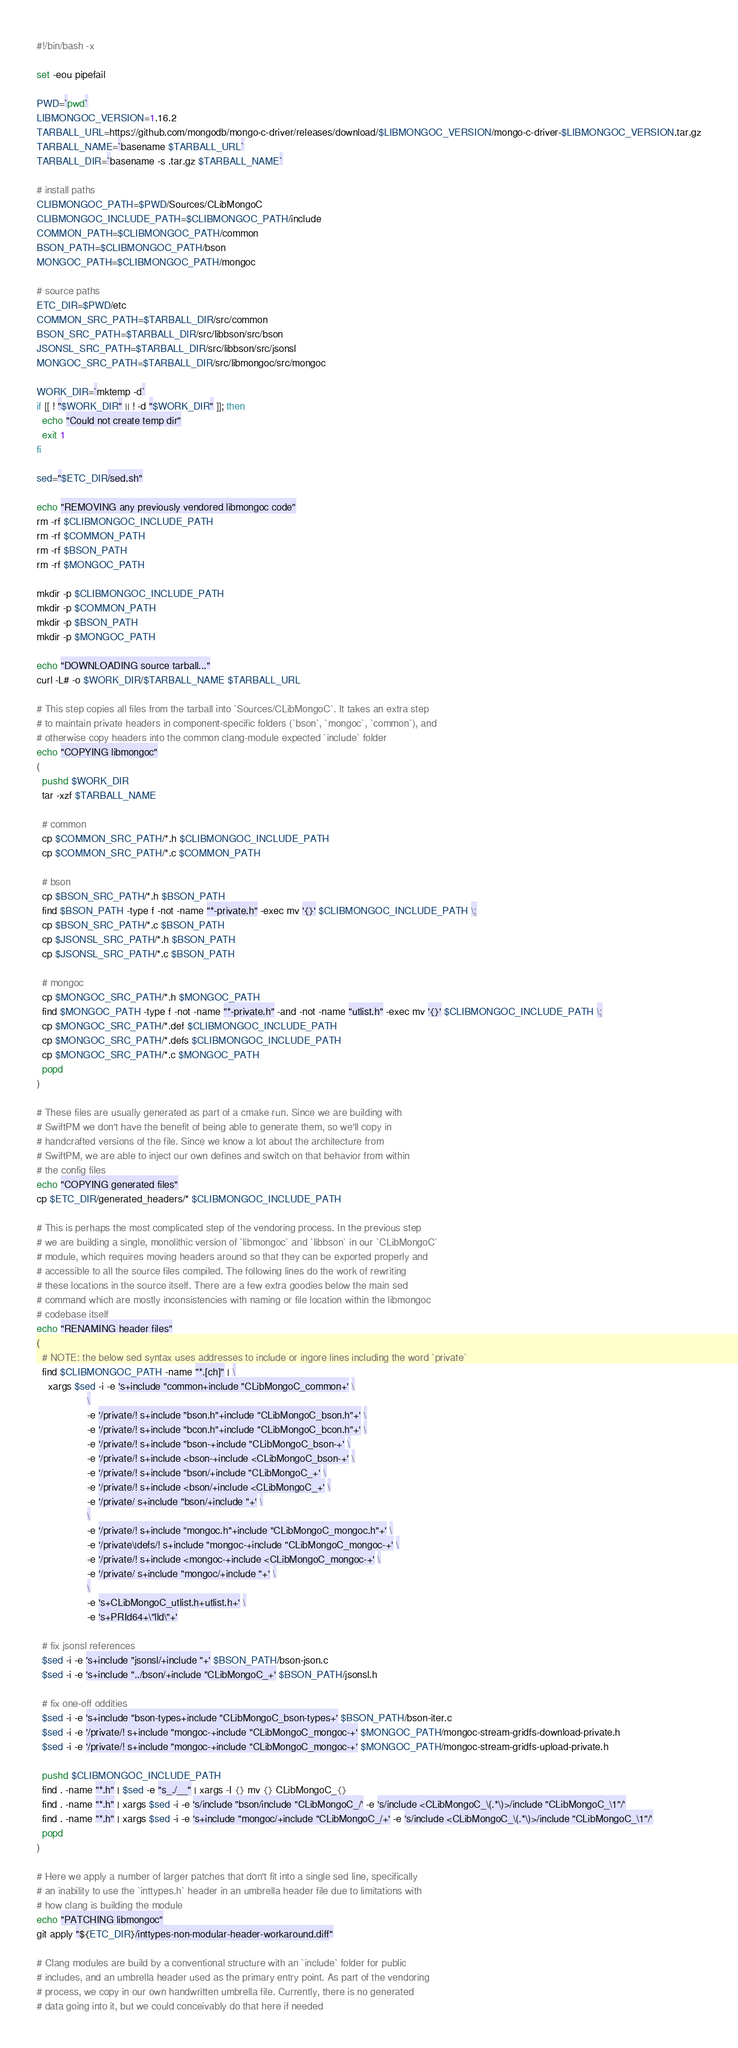<code> <loc_0><loc_0><loc_500><loc_500><_Bash_>#!/bin/bash -x

set -eou pipefail

PWD=`pwd`
LIBMONGOC_VERSION=1.16.2
TARBALL_URL=https://github.com/mongodb/mongo-c-driver/releases/download/$LIBMONGOC_VERSION/mongo-c-driver-$LIBMONGOC_VERSION.tar.gz
TARBALL_NAME=`basename $TARBALL_URL`
TARBALL_DIR=`basename -s .tar.gz $TARBALL_NAME`

# install paths
CLIBMONGOC_PATH=$PWD/Sources/CLibMongoC
CLIBMONGOC_INCLUDE_PATH=$CLIBMONGOC_PATH/include
COMMON_PATH=$CLIBMONGOC_PATH/common
BSON_PATH=$CLIBMONGOC_PATH/bson
MONGOC_PATH=$CLIBMONGOC_PATH/mongoc

# source paths
ETC_DIR=$PWD/etc
COMMON_SRC_PATH=$TARBALL_DIR/src/common
BSON_SRC_PATH=$TARBALL_DIR/src/libbson/src/bson
JSONSL_SRC_PATH=$TARBALL_DIR/src/libbson/src/jsonsl
MONGOC_SRC_PATH=$TARBALL_DIR/src/libmongoc/src/mongoc

WORK_DIR=`mktemp -d`
if [[ ! "$WORK_DIR" || ! -d "$WORK_DIR" ]]; then
  echo "Could not create temp dir"
  exit 1
fi

sed="$ETC_DIR/sed.sh"

echo "REMOVING any previously vendored libmongoc code"
rm -rf $CLIBMONGOC_INCLUDE_PATH
rm -rf $COMMON_PATH
rm -rf $BSON_PATH
rm -rf $MONGOC_PATH

mkdir -p $CLIBMONGOC_INCLUDE_PATH
mkdir -p $COMMON_PATH
mkdir -p $BSON_PATH
mkdir -p $MONGOC_PATH

echo "DOWNLOADING source tarball..."
curl -L# -o $WORK_DIR/$TARBALL_NAME $TARBALL_URL

# This step copies all files from the tarball into `Sources/CLibMongoC`. It takes an extra step
# to maintain private headers in component-specific folders (`bson`, `mongoc`, `common`), and
# otherwise copy headers into the common clang-module expected `include` folder
echo "COPYING libmongoc"
(
  pushd $WORK_DIR
  tar -xzf $TARBALL_NAME

  # common
  cp $COMMON_SRC_PATH/*.h $CLIBMONGOC_INCLUDE_PATH
  cp $COMMON_SRC_PATH/*.c $COMMON_PATH

  # bson
  cp $BSON_SRC_PATH/*.h $BSON_PATH
  find $BSON_PATH -type f -not -name "*-private.h" -exec mv '{}' $CLIBMONGOC_INCLUDE_PATH \;
  cp $BSON_SRC_PATH/*.c $BSON_PATH
  cp $JSONSL_SRC_PATH/*.h $BSON_PATH
  cp $JSONSL_SRC_PATH/*.c $BSON_PATH

  # mongoc
  cp $MONGOC_SRC_PATH/*.h $MONGOC_PATH
  find $MONGOC_PATH -type f -not -name "*-private.h" -and -not -name "utlist.h" -exec mv '{}' $CLIBMONGOC_INCLUDE_PATH \;
  cp $MONGOC_SRC_PATH/*.def $CLIBMONGOC_INCLUDE_PATH
  cp $MONGOC_SRC_PATH/*.defs $CLIBMONGOC_INCLUDE_PATH
  cp $MONGOC_SRC_PATH/*.c $MONGOC_PATH
  popd
)

# These files are usually generated as part of a cmake run. Since we are building with
# SwiftPM we don't have the benefit of being able to generate them, so we'll copy in
# handcrafted versions of the file. Since we know a lot about the architecture from
# SwiftPM, we are able to inject our own defines and switch on that behavior from within
# the config files
echo "COPYING generated files"
cp $ETC_DIR/generated_headers/* $CLIBMONGOC_INCLUDE_PATH

# This is perhaps the most complicated step of the vendoring process. In the previous step
# we are building a single, monolithic version of `libmongoc` and `libbson` in our `CLibMongoC`
# module, which requires moving headers around so that they can be exported properly and
# accessible to all the source files compiled. The following lines do the work of rewriting
# these locations in the source itself. There are a few extra goodies below the main sed
# command which are mostly inconsistencies with naming or file location within the libmongoc
# codebase itself
echo "RENAMING header files"
(
  # NOTE: the below sed syntax uses addresses to include or ingore lines including the word `private`
  find $CLIBMONGOC_PATH -name "*.[ch]" | \
    xargs $sed -i -e 's+include "common+include "CLibMongoC_common+' \
                  \
                  -e '/private/! s+include "bson.h"+include "CLibMongoC_bson.h"+' \
                  -e '/private/! s+include "bcon.h"+include "CLibMongoC_bcon.h"+' \
                  -e '/private/! s+include "bson-+include "CLibMongoC_bson-+' \
                  -e '/private/! s+include <bson-+include <CLibMongoC_bson-+' \
                  -e '/private/! s+include "bson/+include "CLibMongoC_+' \
                  -e '/private/! s+include <bson/+include <CLibMongoC_+' \
                  -e '/private/ s+include "bson/+include "+' \
                  \
                  -e '/private/! s+include "mongoc.h"+include "CLibMongoC_mongoc.h"+' \
                  -e '/private\|defs/! s+include "mongoc-+include "CLibMongoC_mongoc-+' \
                  -e '/private/! s+include <mongoc-+include <CLibMongoC_mongoc-+' \
                  -e '/private/ s+include "mongoc/+include "+' \
                  \
                  -e 's+CLibMongoC_utlist.h+utlist.h+' \
                  -e 's+PRId64+\"lld\"+'

  # fix jsonsl references
  $sed -i -e 's+include "jsonsl/+include "+' $BSON_PATH/bson-json.c
  $sed -i -e 's+include "../bson/+include "CLibMongoC_+' $BSON_PATH/jsonsl.h

  # fix one-off oddities
  $sed -i -e 's+include "bson-types+include "CLibMongoC_bson-types+' $BSON_PATH/bson-iter.c
  $sed -i -e '/private/! s+include "mongoc-+include "CLibMongoC_mongoc-+' $MONGOC_PATH/mongoc-stream-gridfs-download-private.h
  $sed -i -e '/private/! s+include "mongoc-+include "CLibMongoC_mongoc-+' $MONGOC_PATH/mongoc-stream-gridfs-upload-private.h

  pushd $CLIBMONGOC_INCLUDE_PATH
  find . -name "*.h" | $sed -e "s_./__" | xargs -I {} mv {} CLibMongoC_{}
  find . -name "*.h" | xargs $sed -i -e 's/include "bson/include "CLibMongoC_/' -e 's/include <CLibMongoC_\(.*\)>/include "CLibMongoC_\1"/'
  find . -name "*.h" | xargs $sed -i -e 's+include "mongoc/+include "CLibMongoC_/+' -e 's/include <CLibMongoC_\(.*\)>/include "CLibMongoC_\1"/'
  popd
)

# Here we apply a number of larger patches that don't fit into a single sed line, specifically
# an inability to use the `inttypes.h` header in an umbrella header file due to limitations with
# how clang is building the module
echo "PATCHING libmongoc"
git apply "${ETC_DIR}/inttypes-non-modular-header-workaround.diff"

# Clang modules are build by a conventional structure with an `include` folder for public
# includes, and an umbrella header used as the primary entry point. As part of the vendoring
# process, we copy in our own handwritten umbrella file. Currently, there is no generated
# data going into it, but we could conceivably do that here if needed</code> 